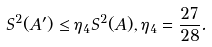<formula> <loc_0><loc_0><loc_500><loc_500>S ^ { 2 } ( A ^ { \prime } ) \leq \eta _ { 4 } S ^ { 2 } ( A ) , \eta _ { 4 } = \frac { 2 7 } { 2 8 } .</formula> 